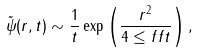Convert formula to latex. <formula><loc_0><loc_0><loc_500><loc_500>\tilde { \psi } ( r , t ) \sim \frac { 1 } { t } \exp \left ( \frac { r ^ { 2 } } { 4 \leq f f t } \right ) ,</formula> 